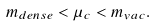<formula> <loc_0><loc_0><loc_500><loc_500>m _ { d e n s e } < \mu _ { c } < m _ { v a c } .</formula> 